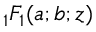Convert formula to latex. <formula><loc_0><loc_0><loc_500><loc_500>{ _ { 1 } F _ { 1 } } ( a ; b ; z )</formula> 